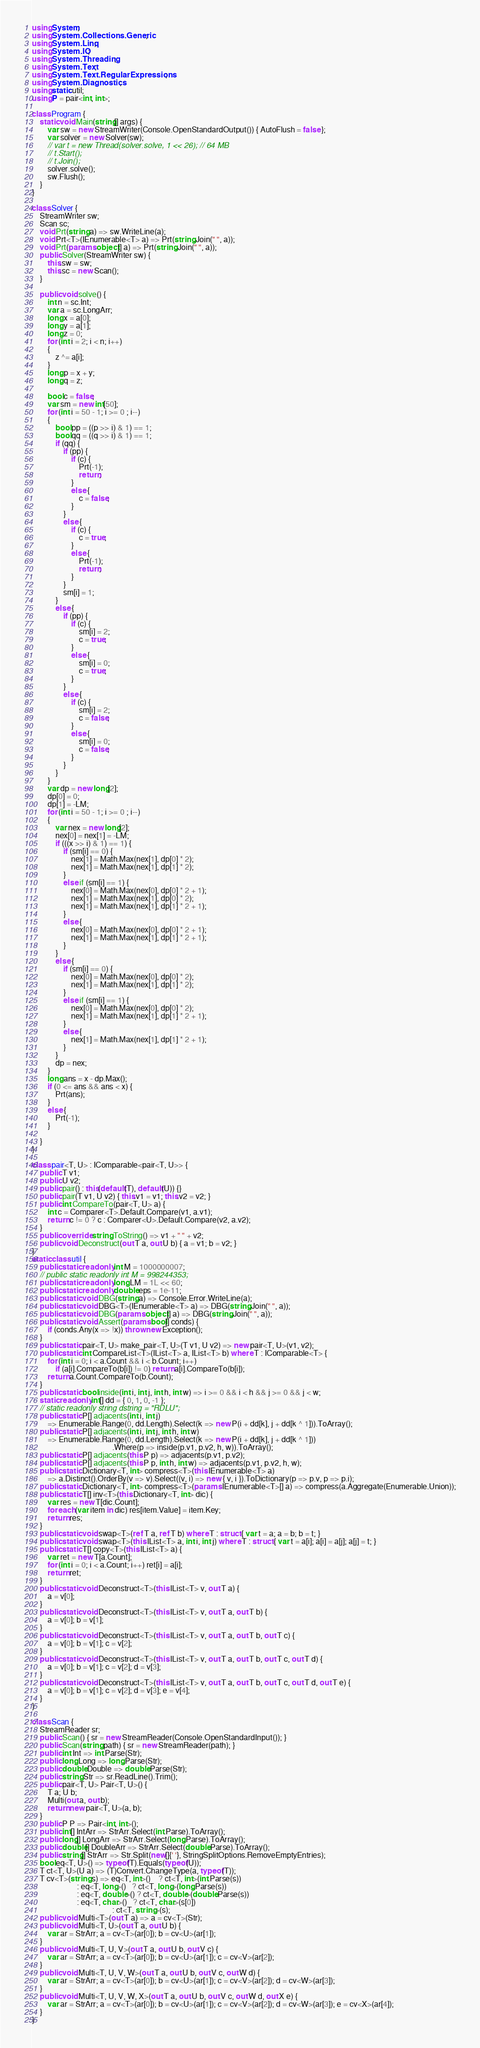Convert code to text. <code><loc_0><loc_0><loc_500><loc_500><_C#_>using System;
using System.Collections.Generic;
using System.Linq;
using System.IO;
using System.Threading;
using System.Text;
using System.Text.RegularExpressions;
using System.Diagnostics;
using static util;
using P = pair<int, int>;

class Program {
    static void Main(string[] args) {
        var sw = new StreamWriter(Console.OpenStandardOutput()) { AutoFlush = false };
        var solver = new Solver(sw);
        // var t = new Thread(solver.solve, 1 << 26); // 64 MB
        // t.Start();
        // t.Join();
        solver.solve();
        sw.Flush();
    }
}

class Solver {
    StreamWriter sw;
    Scan sc;
    void Prt(string a) => sw.WriteLine(a);
    void Prt<T>(IEnumerable<T> a) => Prt(string.Join(" ", a));
    void Prt(params object[] a) => Prt(string.Join(" ", a));
    public Solver(StreamWriter sw) {
        this.sw = sw;
        this.sc = new Scan();
    }

    public void solve() {
        int n = sc.Int;
        var a = sc.LongArr;
        long x = a[0];
        long y = a[1];
        long z = 0;
        for (int i = 2; i < n; i++)
        {
            z ^= a[i];
        }
        long p = x + y;
        long q = z;

        bool c = false;
        var sm = new int[50];
        for (int i = 50 - 1; i >= 0 ; i--)
        {
            bool pp = ((p >> i) & 1) == 1;
            bool qq = ((q >> i) & 1) == 1;
            if (qq) {
                if (pp) {
                    if (c) {
                        Prt(-1);
                        return;
                    }
                    else {
                        c = false;
                    }
                }
                else {
                    if (c) {
                        c = true;
                    }
                    else {
                        Prt(-1);
                        return;
                    }
                }
                sm[i] = 1;
            }
            else {
                if (pp) {
                    if (c) {
                        sm[i] = 2;
                        c = true;
                    }
                    else {
                        sm[i] = 0;
                        c = true;
                    }
                }
                else {
                    if (c) {
                        sm[i] = 2;
                        c = false;
                    }
                    else {
                        sm[i] = 0;
                        c = false;
                    }
                }
            }
        }
        var dp = new long[2];
        dp[0] = 0;
        dp[1] = -LM;
        for (int i = 50 - 1; i >= 0 ; i--)
        {
            var nex = new long[2];
            nex[0] = nex[1] = -LM;
            if (((x >> i) & 1) == 1) {
                if (sm[i] == 0) {
                    nex[1] = Math.Max(nex[1], dp[0] * 2);
                    nex[1] = Math.Max(nex[1], dp[1] * 2);
                }
                else if (sm[i] == 1) {
                    nex[0] = Math.Max(nex[0], dp[0] * 2 + 1);
                    nex[1] = Math.Max(nex[1], dp[0] * 2);
                    nex[1] = Math.Max(nex[1], dp[1] * 2 + 1);
                }
                else {
                    nex[0] = Math.Max(nex[0], dp[0] * 2 + 1);
                    nex[1] = Math.Max(nex[1], dp[1] * 2 + 1);
                }
            }
            else {
                if (sm[i] == 0) {
                    nex[0] = Math.Max(nex[0], dp[0] * 2);
                    nex[1] = Math.Max(nex[1], dp[1] * 2);
                }
                else if (sm[i] == 1) {
                    nex[0] = Math.Max(nex[0], dp[0] * 2);
                    nex[1] = Math.Max(nex[1], dp[1] * 2 + 1);
                }
                else {
                    nex[1] = Math.Max(nex[1], dp[1] * 2 + 1);
                }
            }
            dp = nex;
        }
        long ans = x - dp.Max();
        if (0 <= ans && ans < x) {
            Prt(ans);
        }
        else {
            Prt(-1);
        }

    }
}

class pair<T, U> : IComparable<pair<T, U>> {
    public T v1;
    public U v2;
    public pair() : this(default(T), default(U)) {}
    public pair(T v1, U v2) { this.v1 = v1; this.v2 = v2; }
    public int CompareTo(pair<T, U> a) {
        int c = Comparer<T>.Default.Compare(v1, a.v1);
        return c != 0 ? c : Comparer<U>.Default.Compare(v2, a.v2);
    }
    public override string ToString() => v1 + " " + v2;
    public void Deconstruct(out T a, out U b) { a = v1; b = v2; }
}
static class util {
    public static readonly int M = 1000000007;
    // public static readonly int M = 998244353;
    public static readonly long LM = 1L << 60;
    public static readonly double eps = 1e-11;
    public static void DBG(string a) => Console.Error.WriteLine(a);
    public static void DBG<T>(IEnumerable<T> a) => DBG(string.Join(" ", a));
    public static void DBG(params object[] a) => DBG(string.Join(" ", a));
    public static void Assert(params bool[] conds) {
        if (conds.Any(x => !x)) throw new Exception();
    }
    public static pair<T, U> make_pair<T, U>(T v1, U v2) => new pair<T, U>(v1, v2);
    public static int CompareList<T>(IList<T> a, IList<T> b) where T : IComparable<T> {
        for (int i = 0; i < a.Count && i < b.Count; i++)
            if (a[i].CompareTo(b[i]) != 0) return a[i].CompareTo(b[i]);
        return a.Count.CompareTo(b.Count);
    }
    public static bool inside(int i, int j, int h, int w) => i >= 0 && i < h && j >= 0 && j < w;
    static readonly int[] dd = { 0, 1, 0, -1 };
    // static readonly string dstring = "RDLU";
    public static P[] adjacents(int i, int j)
        => Enumerable.Range(0, dd.Length).Select(k => new P(i + dd[k], j + dd[k ^ 1])).ToArray();
    public static P[] adjacents(int i, int j, int h, int w)
        => Enumerable.Range(0, dd.Length).Select(k => new P(i + dd[k], j + dd[k ^ 1]))
                                         .Where(p => inside(p.v1, p.v2, h, w)).ToArray();
    public static P[] adjacents(this P p) => adjacents(p.v1, p.v2);
    public static P[] adjacents(this P p, int h, int w) => adjacents(p.v1, p.v2, h, w);
    public static Dictionary<T, int> compress<T>(this IEnumerable<T> a)
        => a.Distinct().OrderBy(v => v).Select((v, i) => new { v, i }).ToDictionary(p => p.v, p => p.i);
    public static Dictionary<T, int> compress<T>(params IEnumerable<T>[] a) => compress(a.Aggregate(Enumerable.Union));
    public static T[] inv<T>(this Dictionary<T, int> dic) {
        var res = new T[dic.Count];
        foreach (var item in dic) res[item.Value] = item.Key;
        return res;
    }
    public static void swap<T>(ref T a, ref T b) where T : struct { var t = a; a = b; b = t; }
    public static void swap<T>(this IList<T> a, int i, int j) where T : struct { var t = a[i]; a[i] = a[j]; a[j] = t; }
    public static T[] copy<T>(this IList<T> a) {
        var ret = new T[a.Count];
        for (int i = 0; i < a.Count; i++) ret[i] = a[i];
        return ret;
    }
    public static void Deconstruct<T>(this IList<T> v, out T a) {
        a = v[0];
    }
    public static void Deconstruct<T>(this IList<T> v, out T a, out T b) {
        a = v[0]; b = v[1];
    }
    public static void Deconstruct<T>(this IList<T> v, out T a, out T b, out T c) {
        a = v[0]; b = v[1]; c = v[2];
    }
    public static void Deconstruct<T>(this IList<T> v, out T a, out T b, out T c, out T d) {
        a = v[0]; b = v[1]; c = v[2]; d = v[3];
    }
    public static void Deconstruct<T>(this IList<T> v, out T a, out T b, out T c, out T d, out T e) {
        a = v[0]; b = v[1]; c = v[2]; d = v[3]; e = v[4];
    }
}

class Scan {
    StreamReader sr;
    public Scan() { sr = new StreamReader(Console.OpenStandardInput()); }
    public Scan(string path) { sr = new StreamReader(path); }
    public int Int => int.Parse(Str);
    public long Long => long.Parse(Str);
    public double Double => double.Parse(Str);
    public string Str => sr.ReadLine().Trim();
    public pair<T, U> Pair<T, U>() {
        T a; U b;
        Multi(out a, out b);
        return new pair<T, U>(a, b);
    }
    public P P => Pair<int, int>();
    public int[] IntArr => StrArr.Select(int.Parse).ToArray();
    public long[] LongArr => StrArr.Select(long.Parse).ToArray();
    public double[] DoubleArr => StrArr.Select(double.Parse).ToArray();
    public string[] StrArr => Str.Split(new[]{' '}, StringSplitOptions.RemoveEmptyEntries);
    bool eq<T, U>() => typeof(T).Equals(typeof(U));
    T ct<T, U>(U a) => (T)Convert.ChangeType(a, typeof(T));
    T cv<T>(string s) => eq<T, int>()    ? ct<T, int>(int.Parse(s))
                       : eq<T, long>()   ? ct<T, long>(long.Parse(s))
                       : eq<T, double>() ? ct<T, double>(double.Parse(s))
                       : eq<T, char>()   ? ct<T, char>(s[0])
                                         : ct<T, string>(s);
    public void Multi<T>(out T a) => a = cv<T>(Str);
    public void Multi<T, U>(out T a, out U b) {
        var ar = StrArr; a = cv<T>(ar[0]); b = cv<U>(ar[1]);
    }
    public void Multi<T, U, V>(out T a, out U b, out V c) {
        var ar = StrArr; a = cv<T>(ar[0]); b = cv<U>(ar[1]); c = cv<V>(ar[2]);
    }
    public void Multi<T, U, V, W>(out T a, out U b, out V c, out W d) {
        var ar = StrArr; a = cv<T>(ar[0]); b = cv<U>(ar[1]); c = cv<V>(ar[2]); d = cv<W>(ar[3]);
    }
    public void Multi<T, U, V, W, X>(out T a, out U b, out V c, out W d, out X e) {
        var ar = StrArr; a = cv<T>(ar[0]); b = cv<U>(ar[1]); c = cv<V>(ar[2]); d = cv<W>(ar[3]); e = cv<X>(ar[4]);
    }
}
</code> 